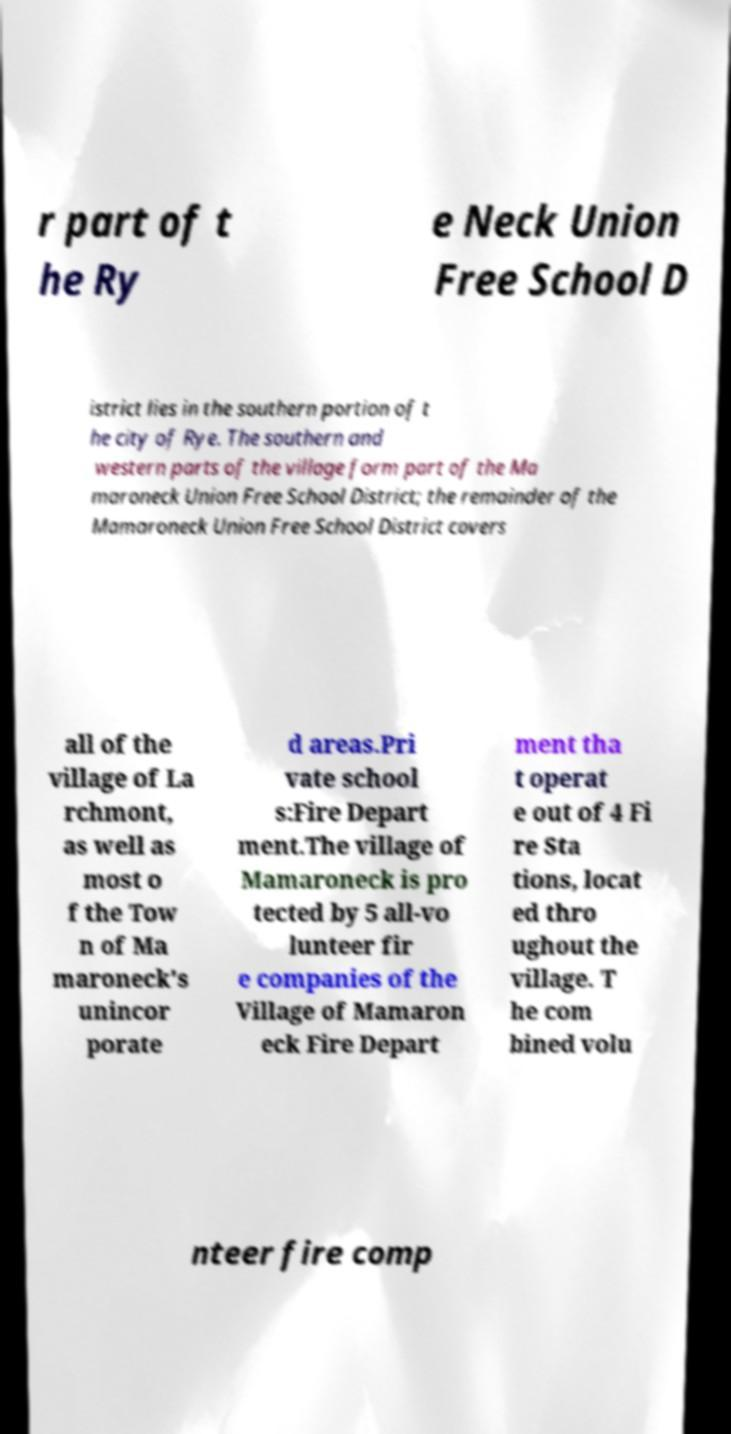Can you read and provide the text displayed in the image?This photo seems to have some interesting text. Can you extract and type it out for me? r part of t he Ry e Neck Union Free School D istrict lies in the southern portion of t he city of Rye. The southern and western parts of the village form part of the Ma maroneck Union Free School District; the remainder of the Mamaroneck Union Free School District covers all of the village of La rchmont, as well as most o f the Tow n of Ma maroneck's unincor porate d areas.Pri vate school s:Fire Depart ment.The village of Mamaroneck is pro tected by 5 all-vo lunteer fir e companies of the Village of Mamaron eck Fire Depart ment tha t operat e out of 4 Fi re Sta tions, locat ed thro ughout the village. T he com bined volu nteer fire comp 